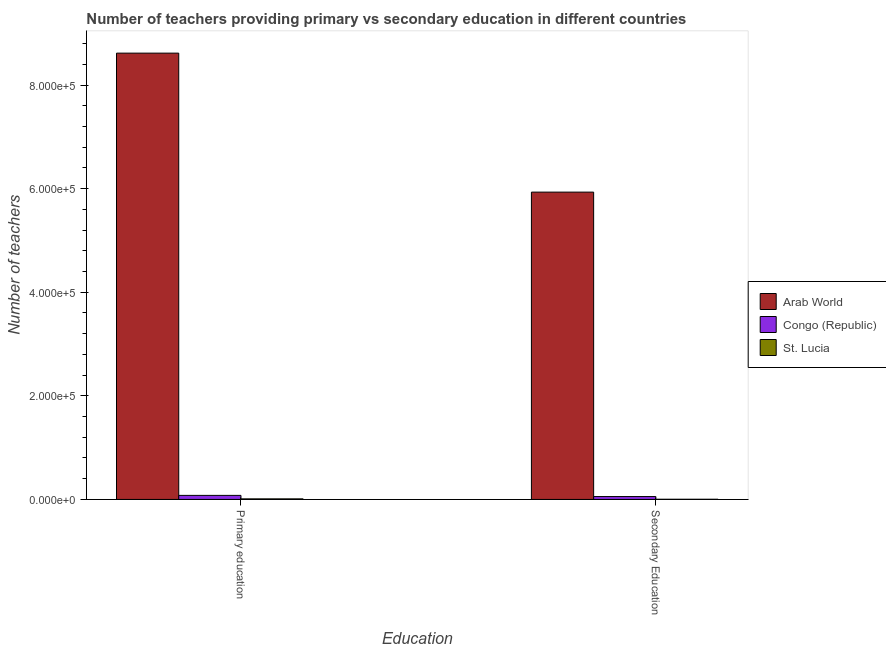How many different coloured bars are there?
Keep it short and to the point. 3. How many groups of bars are there?
Give a very brief answer. 2. How many bars are there on the 2nd tick from the left?
Give a very brief answer. 3. How many bars are there on the 1st tick from the right?
Offer a very short reply. 3. What is the number of primary teachers in Arab World?
Your response must be concise. 8.62e+05. Across all countries, what is the maximum number of primary teachers?
Your answer should be compact. 8.62e+05. Across all countries, what is the minimum number of secondary teachers?
Provide a succinct answer. 333. In which country was the number of primary teachers maximum?
Offer a terse response. Arab World. In which country was the number of secondary teachers minimum?
Provide a short and direct response. St. Lucia. What is the total number of primary teachers in the graph?
Make the answer very short. 8.70e+05. What is the difference between the number of secondary teachers in Arab World and that in St. Lucia?
Offer a terse response. 5.93e+05. What is the difference between the number of secondary teachers in St. Lucia and the number of primary teachers in Congo (Republic)?
Offer a very short reply. -7470. What is the average number of primary teachers per country?
Provide a short and direct response. 2.90e+05. What is the difference between the number of secondary teachers and number of primary teachers in Congo (Republic)?
Make the answer very short. -2266. What is the ratio of the number of secondary teachers in Congo (Republic) to that in St. Lucia?
Your answer should be very brief. 16.63. Is the number of secondary teachers in Congo (Republic) less than that in Arab World?
Your answer should be very brief. Yes. What does the 3rd bar from the left in Primary education represents?
Offer a very short reply. St. Lucia. What does the 1st bar from the right in Primary education represents?
Your response must be concise. St. Lucia. How many countries are there in the graph?
Provide a succinct answer. 3. What is the difference between two consecutive major ticks on the Y-axis?
Ensure brevity in your answer.  2.00e+05. Are the values on the major ticks of Y-axis written in scientific E-notation?
Ensure brevity in your answer.  Yes. Does the graph contain any zero values?
Your answer should be very brief. No. Does the graph contain grids?
Your answer should be very brief. No. How many legend labels are there?
Offer a very short reply. 3. How are the legend labels stacked?
Keep it short and to the point. Vertical. What is the title of the graph?
Make the answer very short. Number of teachers providing primary vs secondary education in different countries. What is the label or title of the X-axis?
Give a very brief answer. Education. What is the label or title of the Y-axis?
Give a very brief answer. Number of teachers. What is the Number of teachers in Arab World in Primary education?
Provide a short and direct response. 8.62e+05. What is the Number of teachers in Congo (Republic) in Primary education?
Offer a very short reply. 7803. What is the Number of teachers of St. Lucia in Primary education?
Make the answer very short. 1084. What is the Number of teachers in Arab World in Secondary Education?
Provide a succinct answer. 5.93e+05. What is the Number of teachers in Congo (Republic) in Secondary Education?
Provide a short and direct response. 5537. What is the Number of teachers in St. Lucia in Secondary Education?
Give a very brief answer. 333. Across all Education, what is the maximum Number of teachers in Arab World?
Your answer should be very brief. 8.62e+05. Across all Education, what is the maximum Number of teachers of Congo (Republic)?
Your response must be concise. 7803. Across all Education, what is the maximum Number of teachers in St. Lucia?
Offer a terse response. 1084. Across all Education, what is the minimum Number of teachers in Arab World?
Offer a very short reply. 5.93e+05. Across all Education, what is the minimum Number of teachers of Congo (Republic)?
Offer a terse response. 5537. Across all Education, what is the minimum Number of teachers of St. Lucia?
Provide a succinct answer. 333. What is the total Number of teachers in Arab World in the graph?
Make the answer very short. 1.45e+06. What is the total Number of teachers of Congo (Republic) in the graph?
Provide a succinct answer. 1.33e+04. What is the total Number of teachers in St. Lucia in the graph?
Offer a very short reply. 1417. What is the difference between the Number of teachers of Arab World in Primary education and that in Secondary Education?
Offer a very short reply. 2.68e+05. What is the difference between the Number of teachers of Congo (Republic) in Primary education and that in Secondary Education?
Offer a very short reply. 2266. What is the difference between the Number of teachers of St. Lucia in Primary education and that in Secondary Education?
Keep it short and to the point. 751. What is the difference between the Number of teachers in Arab World in Primary education and the Number of teachers in Congo (Republic) in Secondary Education?
Give a very brief answer. 8.56e+05. What is the difference between the Number of teachers in Arab World in Primary education and the Number of teachers in St. Lucia in Secondary Education?
Offer a terse response. 8.61e+05. What is the difference between the Number of teachers in Congo (Republic) in Primary education and the Number of teachers in St. Lucia in Secondary Education?
Give a very brief answer. 7470. What is the average Number of teachers in Arab World per Education?
Your answer should be very brief. 7.27e+05. What is the average Number of teachers in Congo (Republic) per Education?
Provide a succinct answer. 6670. What is the average Number of teachers in St. Lucia per Education?
Ensure brevity in your answer.  708.5. What is the difference between the Number of teachers of Arab World and Number of teachers of Congo (Republic) in Primary education?
Your answer should be very brief. 8.54e+05. What is the difference between the Number of teachers of Arab World and Number of teachers of St. Lucia in Primary education?
Your answer should be very brief. 8.60e+05. What is the difference between the Number of teachers of Congo (Republic) and Number of teachers of St. Lucia in Primary education?
Your response must be concise. 6719. What is the difference between the Number of teachers of Arab World and Number of teachers of Congo (Republic) in Secondary Education?
Give a very brief answer. 5.88e+05. What is the difference between the Number of teachers in Arab World and Number of teachers in St. Lucia in Secondary Education?
Offer a very short reply. 5.93e+05. What is the difference between the Number of teachers of Congo (Republic) and Number of teachers of St. Lucia in Secondary Education?
Your answer should be very brief. 5204. What is the ratio of the Number of teachers of Arab World in Primary education to that in Secondary Education?
Make the answer very short. 1.45. What is the ratio of the Number of teachers of Congo (Republic) in Primary education to that in Secondary Education?
Give a very brief answer. 1.41. What is the ratio of the Number of teachers in St. Lucia in Primary education to that in Secondary Education?
Keep it short and to the point. 3.26. What is the difference between the highest and the second highest Number of teachers in Arab World?
Ensure brevity in your answer.  2.68e+05. What is the difference between the highest and the second highest Number of teachers of Congo (Republic)?
Make the answer very short. 2266. What is the difference between the highest and the second highest Number of teachers in St. Lucia?
Make the answer very short. 751. What is the difference between the highest and the lowest Number of teachers of Arab World?
Offer a very short reply. 2.68e+05. What is the difference between the highest and the lowest Number of teachers of Congo (Republic)?
Give a very brief answer. 2266. What is the difference between the highest and the lowest Number of teachers in St. Lucia?
Your response must be concise. 751. 